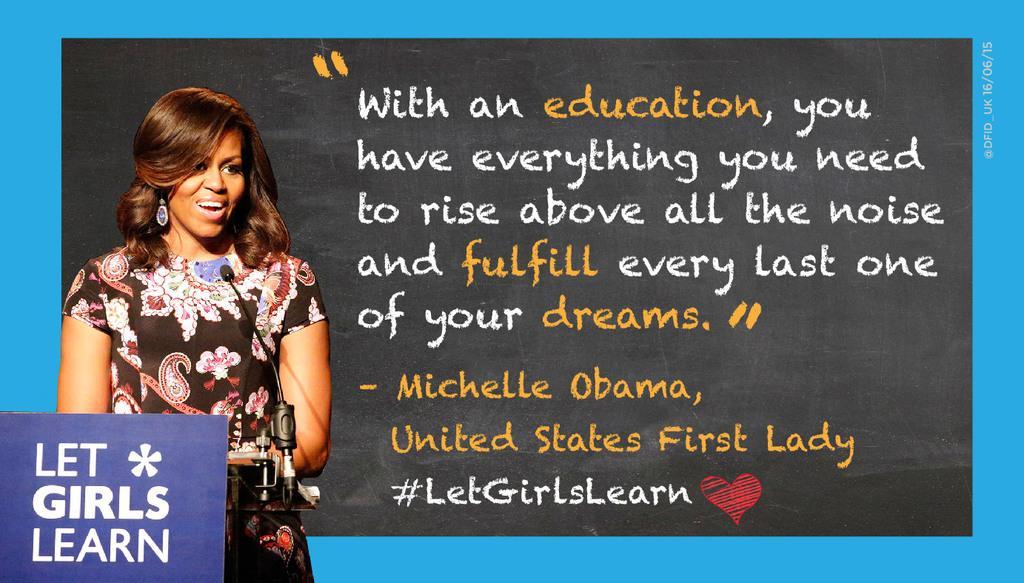Please provide a concise description of this image. On the left side of the image we can see woman standing at the mic. On the right side of the image there is a text. 